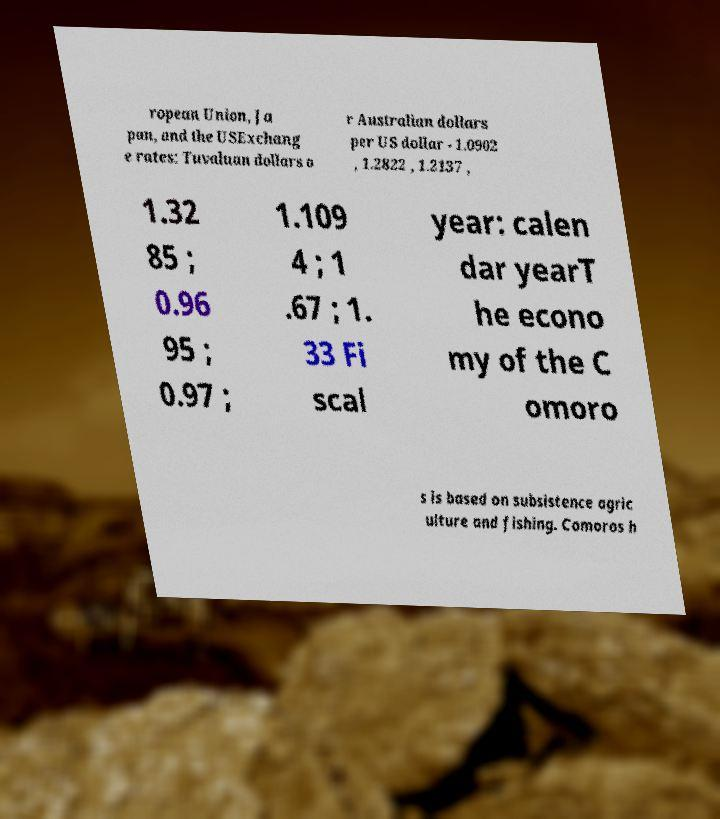For documentation purposes, I need the text within this image transcribed. Could you provide that? ropean Union, Ja pan, and the USExchang e rates: Tuvaluan dollars o r Australian dollars per US dollar - 1.0902 , 1.2822 , 1.2137 , 1.32 85 ; 0.96 95 ; 0.97 ; 1.109 4 ; 1 .67 ; 1. 33 Fi scal year: calen dar yearT he econo my of the C omoro s is based on subsistence agric ulture and fishing. Comoros h 